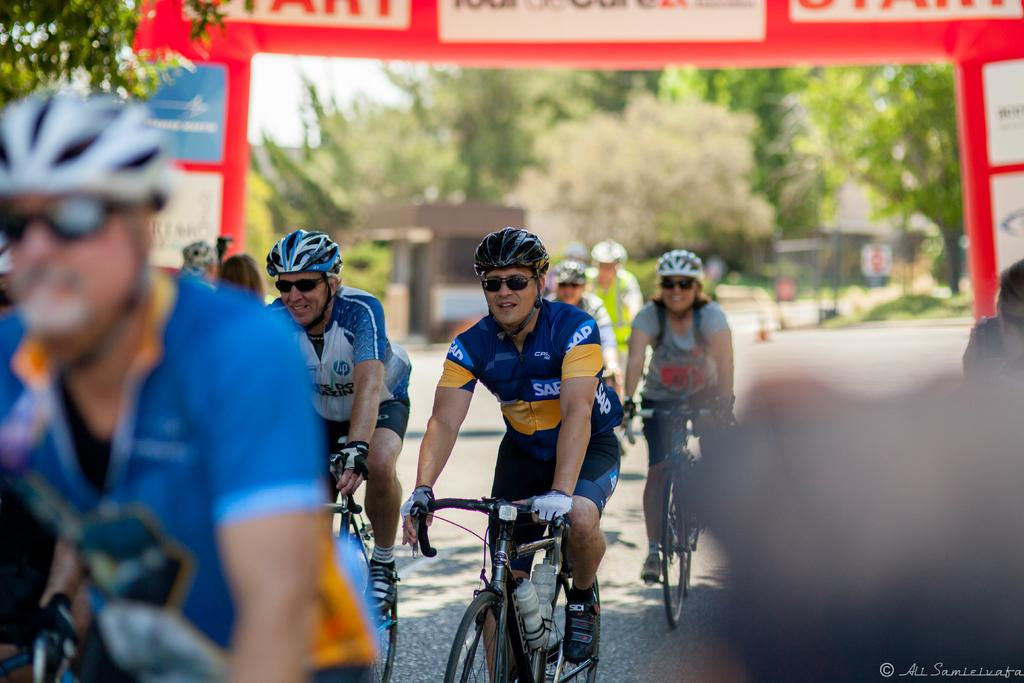What activity are the people in the image engaged in? The people are riding bicycles in the image. What type of event are they participating in? The people are participating in a race. What protective gear are the riders wearing? The riders are wearing glasses and helmets. What can be seen in the background of the image? There is a red-colored hoarding and trees visible in the background. Can you tell me how many times the rider bites the foot of their bicycle during the race? There is no mention of anyone biting a foot in the image, and bicycles do not have feet to bite. 